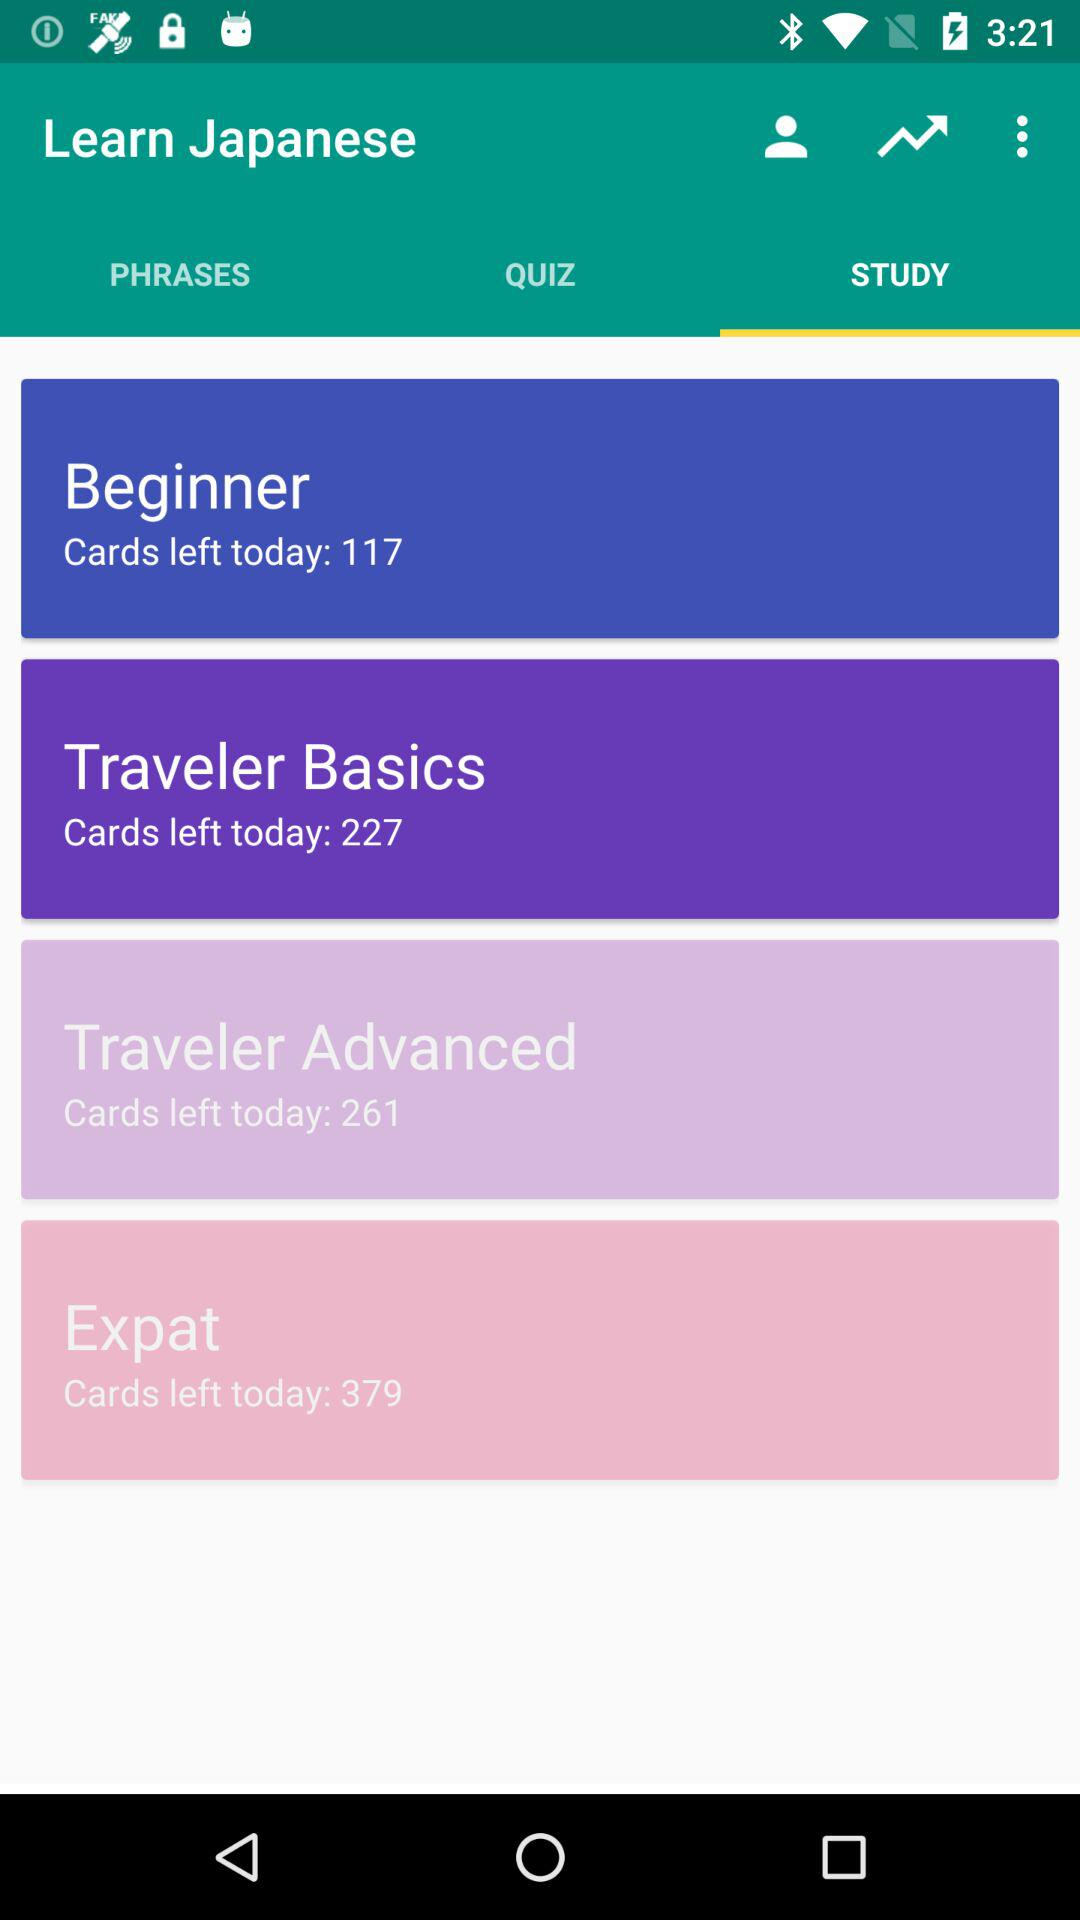How many cards are left today in "Beginner"? There are 117 cards left today in "Beginner". 